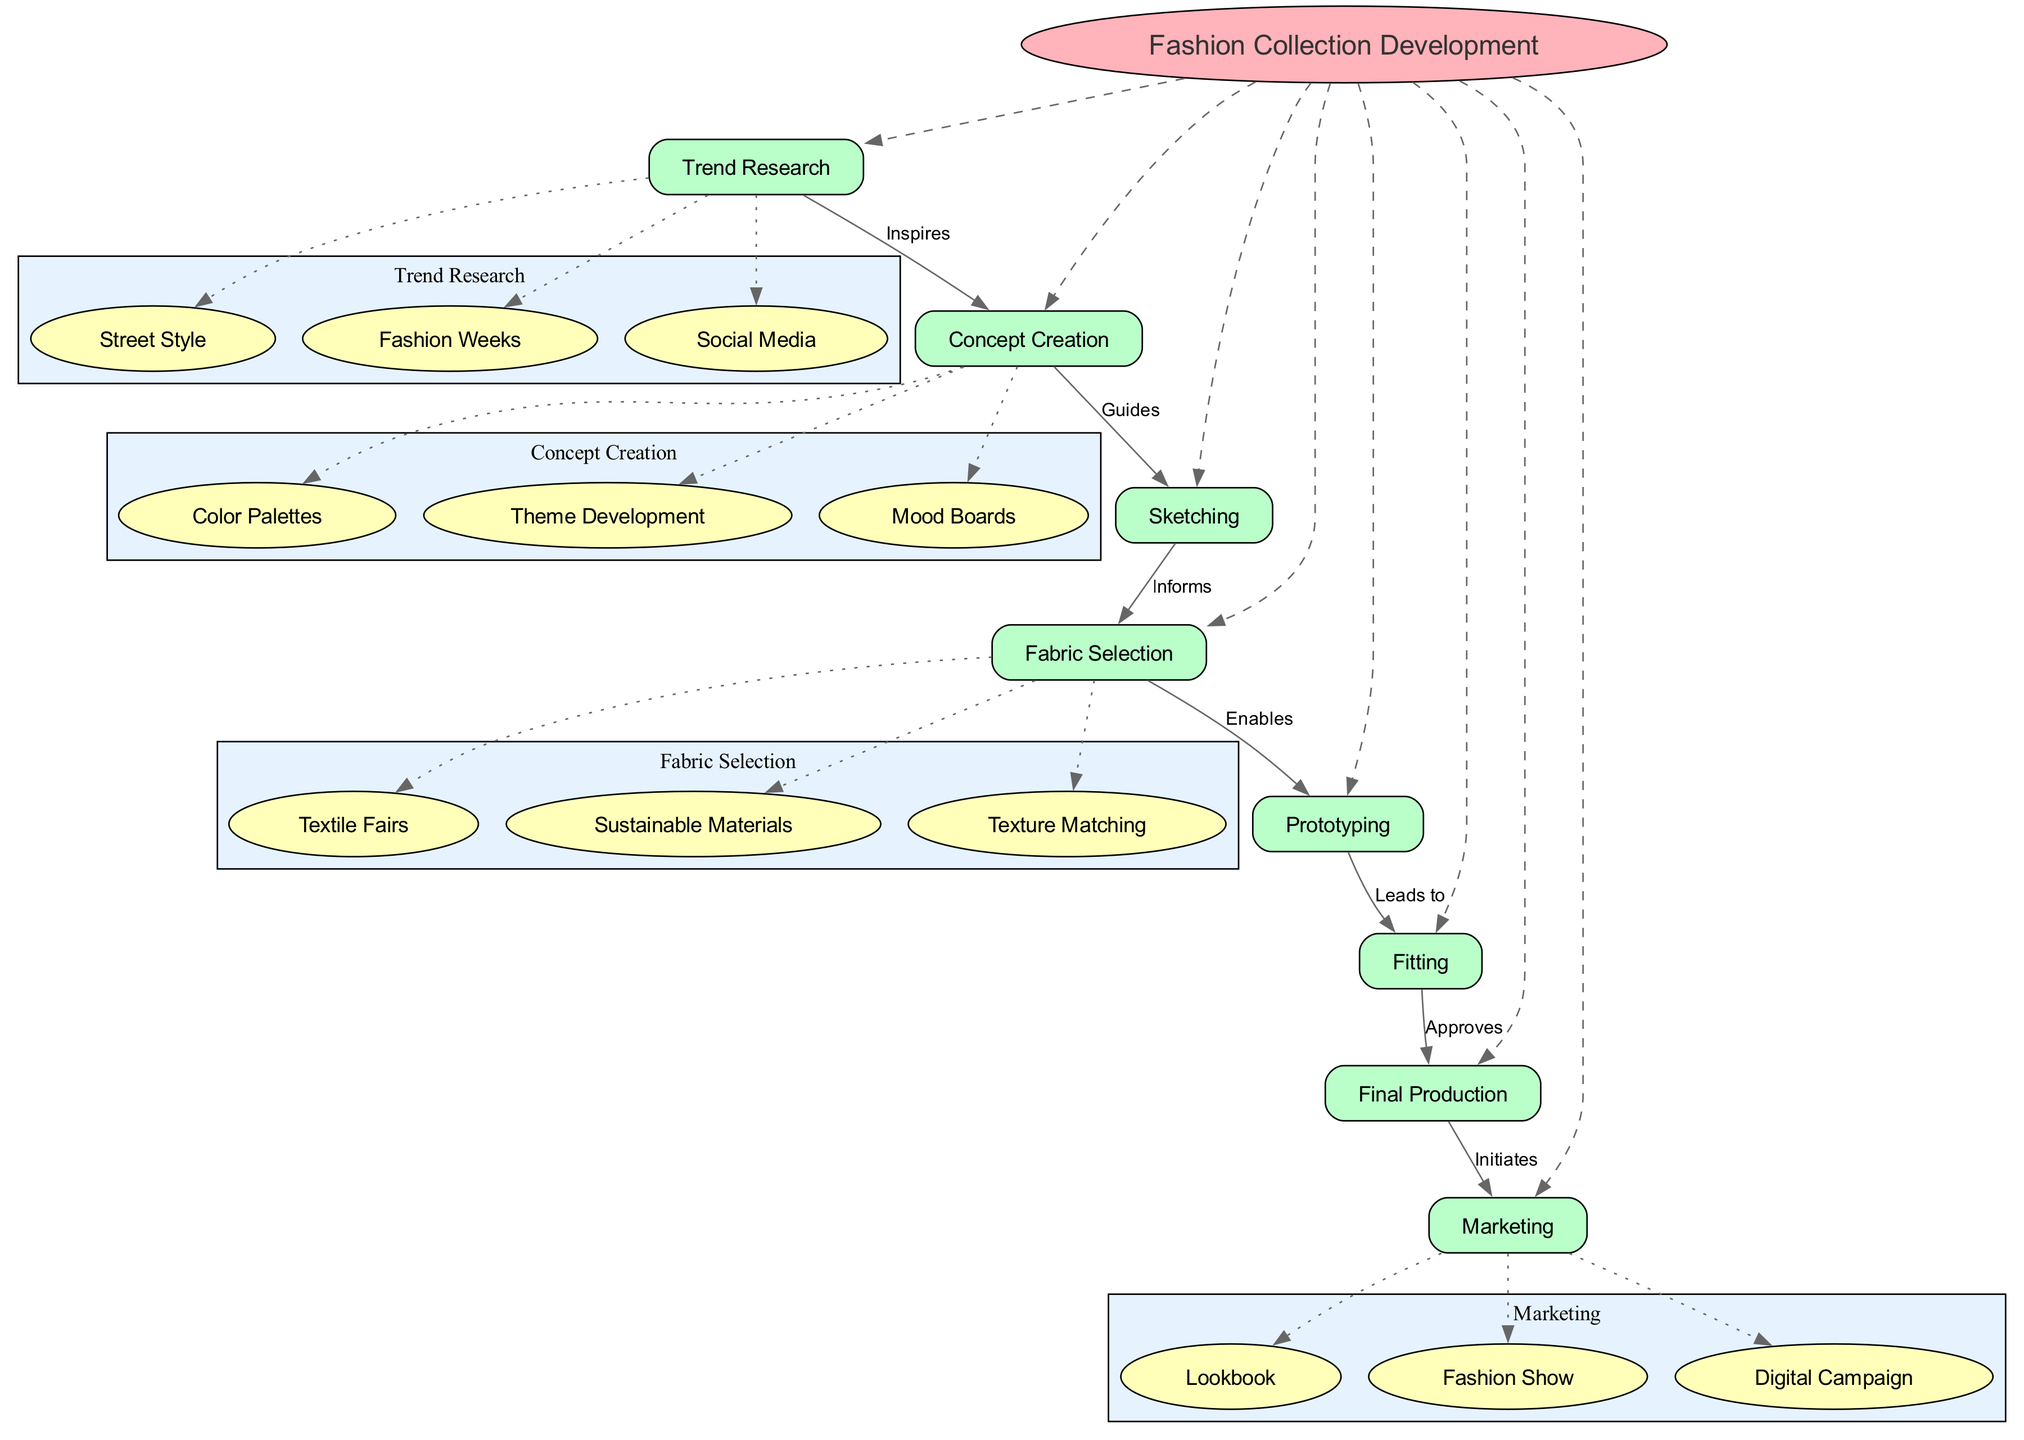What is the central concept of this diagram? The central concept is clearly labeled at the center of the diagram as "Fashion Collection Development".
Answer: Fashion Collection Development How many main nodes are present? Counting the main nodes listed in the diagram, there are a total of eight nodes connected to the central concept.
Answer: 8 What does "Trend Research" inspire? The arrow from "Trend Research" to "Concept Creation" illustrates that it inspires "Concept Creation".
Answer: Concept Creation Which stage comes immediately after "Prototyping"? The diagram shows a direct connection from "Prototyping" to "Fitting", indicating that "Fitting" comes next.
Answer: Fitting What is the last node in the collection development process? The final production step connects to marketing, making "Marketing" the last stage in the development process.
Answer: Marketing How many sub-elements are listed under "Fabric Selection"? There are three children nodes listed under "Fabric Selection" as displayed in the diagram.
Answer: 3 What is the relationship between "Fitting" and "Final Production"? The label on the edge indicates that "Fitting" approves the process before moving on to "Final Production".
Answer: Approves Which main node guides the sketching process? The relationship shown from "Concept Creation" to "Sketching" suggests that "Concept Creation" guides this step.
Answer: Concept Creation What initiates the marketing process? The diagram connects "Final Production" to "Marketing" with a label indicating that "Final Production" initiates marketing.
Answer: Final Production 